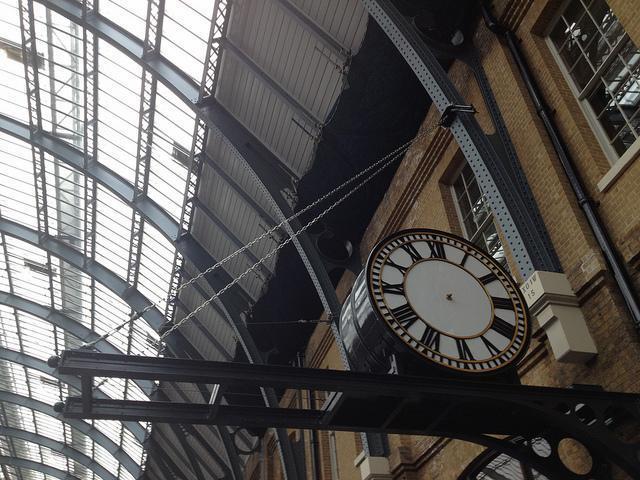How many clocks are there?
Give a very brief answer. 1. How many people have remotes in their hands?
Give a very brief answer. 0. 